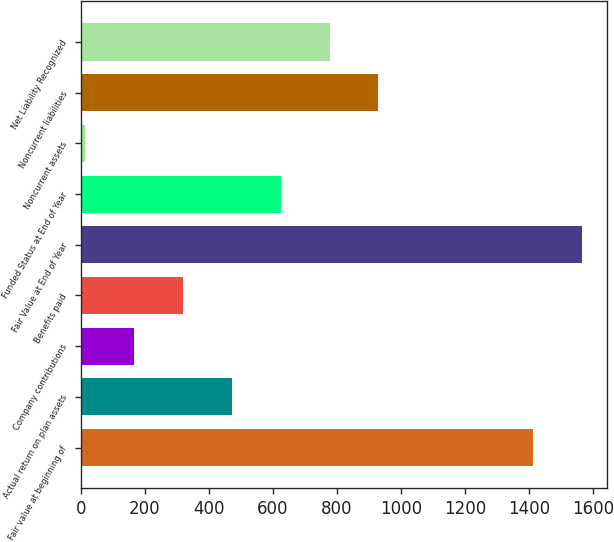Convert chart. <chart><loc_0><loc_0><loc_500><loc_500><bar_chart><fcel>Fair value at beginning of<fcel>Actual return on plan assets<fcel>Company contributions<fcel>Benefits paid<fcel>Fair Value at End of Year<fcel>Funded Status at End of Year<fcel>Noncurrent assets<fcel>Noncurrent liabilities<fcel>Net Liability Recognized<nl><fcel>1411.1<fcel>471.17<fcel>165.79<fcel>318.48<fcel>1563.79<fcel>623.86<fcel>13.1<fcel>929.24<fcel>776.55<nl></chart> 